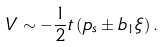Convert formula to latex. <formula><loc_0><loc_0><loc_500><loc_500>V \sim - \frac { 1 } { 2 } t \left ( p _ { s } \pm b _ { 1 } \xi \right ) .</formula> 